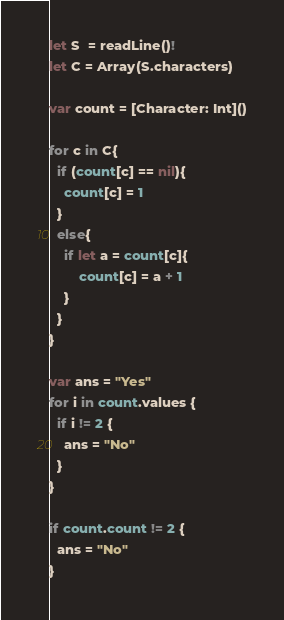<code> <loc_0><loc_0><loc_500><loc_500><_Swift_>let S  = readLine()!
let C = Array(S.characters)

var count = [Character: Int]()

for c in C{
  if (count[c] == nil){
    count[c] = 1
  }
  else{
    if let a = count[c]{
    	count[c] = a + 1
    }
  }
}

var ans = "Yes"
for i in count.values {
  if i != 2 {
    ans = "No"
  }
}

if count.count != 2 {
  ans = "No"
}</code> 